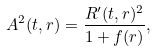<formula> <loc_0><loc_0><loc_500><loc_500>A ^ { 2 } ( t , r ) = \frac { R ^ { \prime } ( t , r ) ^ { 2 } } { 1 + f ( r ) } ,</formula> 